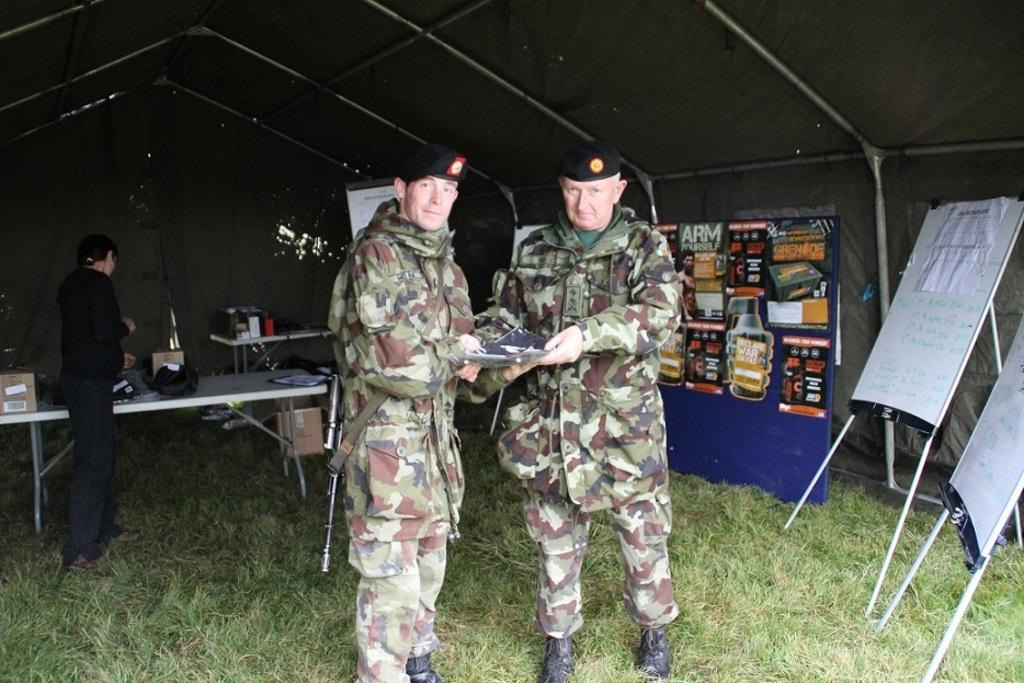How many people are in the image? There are two persons standing in the image. What is the surface they are standing on? The persons are standing on grass. What type of furniture can be seen in the image? There are tables in the image. What other objects are present in the image? There are boards and a banner in the image. What type of seed is being taught by the person in the image? There is no indication in the image that a person is teaching or that seeds are involved. 